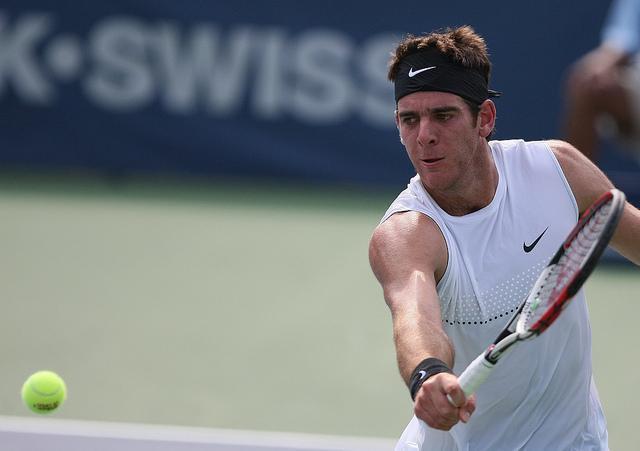How many people are there?
Give a very brief answer. 2. How many kites are there?
Give a very brief answer. 0. 